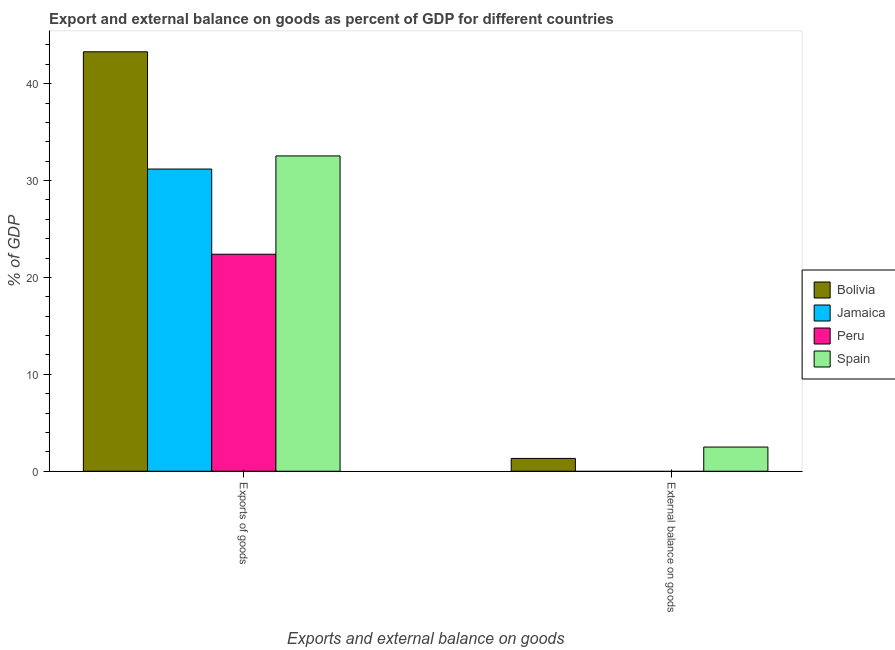How many different coloured bars are there?
Offer a very short reply. 4. How many groups of bars are there?
Ensure brevity in your answer.  2. Are the number of bars on each tick of the X-axis equal?
Your answer should be compact. No. What is the label of the 1st group of bars from the left?
Provide a succinct answer. Exports of goods. What is the external balance on goods as percentage of gdp in Jamaica?
Give a very brief answer. 0. Across all countries, what is the maximum external balance on goods as percentage of gdp?
Your response must be concise. 2.49. What is the total external balance on goods as percentage of gdp in the graph?
Ensure brevity in your answer.  3.82. What is the difference between the export of goods as percentage of gdp in Peru and that in Spain?
Give a very brief answer. -10.15. What is the difference between the external balance on goods as percentage of gdp in Jamaica and the export of goods as percentage of gdp in Spain?
Provide a short and direct response. -32.55. What is the average external balance on goods as percentage of gdp per country?
Provide a succinct answer. 0.95. What is the difference between the export of goods as percentage of gdp and external balance on goods as percentage of gdp in Bolivia?
Offer a very short reply. 41.97. In how many countries, is the external balance on goods as percentage of gdp greater than 8 %?
Your answer should be very brief. 0. What is the ratio of the export of goods as percentage of gdp in Bolivia to that in Peru?
Provide a short and direct response. 1.93. Is the export of goods as percentage of gdp in Jamaica less than that in Peru?
Provide a succinct answer. No. Are all the bars in the graph horizontal?
Ensure brevity in your answer.  No. How many countries are there in the graph?
Keep it short and to the point. 4. Are the values on the major ticks of Y-axis written in scientific E-notation?
Your answer should be very brief. No. Does the graph contain any zero values?
Your answer should be compact. Yes. How many legend labels are there?
Provide a short and direct response. 4. What is the title of the graph?
Your answer should be very brief. Export and external balance on goods as percent of GDP for different countries. What is the label or title of the X-axis?
Provide a short and direct response. Exports and external balance on goods. What is the label or title of the Y-axis?
Offer a terse response. % of GDP. What is the % of GDP in Bolivia in Exports of goods?
Make the answer very short. 43.29. What is the % of GDP of Jamaica in Exports of goods?
Keep it short and to the point. 31.19. What is the % of GDP of Peru in Exports of goods?
Offer a terse response. 22.4. What is the % of GDP of Spain in Exports of goods?
Offer a terse response. 32.55. What is the % of GDP in Bolivia in External balance on goods?
Your answer should be compact. 1.32. What is the % of GDP in Jamaica in External balance on goods?
Your answer should be compact. 0. What is the % of GDP of Spain in External balance on goods?
Your response must be concise. 2.49. Across all Exports and external balance on goods, what is the maximum % of GDP in Bolivia?
Make the answer very short. 43.29. Across all Exports and external balance on goods, what is the maximum % of GDP of Jamaica?
Offer a very short reply. 31.19. Across all Exports and external balance on goods, what is the maximum % of GDP in Peru?
Give a very brief answer. 22.4. Across all Exports and external balance on goods, what is the maximum % of GDP in Spain?
Offer a terse response. 32.55. Across all Exports and external balance on goods, what is the minimum % of GDP in Bolivia?
Make the answer very short. 1.32. Across all Exports and external balance on goods, what is the minimum % of GDP of Jamaica?
Keep it short and to the point. 0. Across all Exports and external balance on goods, what is the minimum % of GDP of Spain?
Your answer should be very brief. 2.49. What is the total % of GDP of Bolivia in the graph?
Offer a very short reply. 44.61. What is the total % of GDP in Jamaica in the graph?
Keep it short and to the point. 31.19. What is the total % of GDP of Peru in the graph?
Make the answer very short. 22.4. What is the total % of GDP in Spain in the graph?
Offer a terse response. 35.04. What is the difference between the % of GDP in Bolivia in Exports of goods and that in External balance on goods?
Ensure brevity in your answer.  41.97. What is the difference between the % of GDP of Spain in Exports of goods and that in External balance on goods?
Give a very brief answer. 30.05. What is the difference between the % of GDP in Bolivia in Exports of goods and the % of GDP in Spain in External balance on goods?
Your answer should be very brief. 40.8. What is the difference between the % of GDP of Jamaica in Exports of goods and the % of GDP of Spain in External balance on goods?
Your answer should be compact. 28.7. What is the difference between the % of GDP in Peru in Exports of goods and the % of GDP in Spain in External balance on goods?
Your response must be concise. 19.9. What is the average % of GDP of Bolivia per Exports and external balance on goods?
Offer a very short reply. 22.31. What is the average % of GDP in Jamaica per Exports and external balance on goods?
Your answer should be very brief. 15.6. What is the average % of GDP in Peru per Exports and external balance on goods?
Your answer should be compact. 11.2. What is the average % of GDP in Spain per Exports and external balance on goods?
Provide a succinct answer. 17.52. What is the difference between the % of GDP in Bolivia and % of GDP in Jamaica in Exports of goods?
Ensure brevity in your answer.  12.1. What is the difference between the % of GDP in Bolivia and % of GDP in Peru in Exports of goods?
Offer a terse response. 20.89. What is the difference between the % of GDP in Bolivia and % of GDP in Spain in Exports of goods?
Offer a terse response. 10.75. What is the difference between the % of GDP in Jamaica and % of GDP in Peru in Exports of goods?
Your answer should be compact. 8.79. What is the difference between the % of GDP of Jamaica and % of GDP of Spain in Exports of goods?
Ensure brevity in your answer.  -1.35. What is the difference between the % of GDP in Peru and % of GDP in Spain in Exports of goods?
Your answer should be compact. -10.15. What is the difference between the % of GDP of Bolivia and % of GDP of Spain in External balance on goods?
Your answer should be compact. -1.17. What is the ratio of the % of GDP in Bolivia in Exports of goods to that in External balance on goods?
Your answer should be compact. 32.76. What is the ratio of the % of GDP in Spain in Exports of goods to that in External balance on goods?
Give a very brief answer. 13.05. What is the difference between the highest and the second highest % of GDP in Bolivia?
Your response must be concise. 41.97. What is the difference between the highest and the second highest % of GDP in Spain?
Give a very brief answer. 30.05. What is the difference between the highest and the lowest % of GDP of Bolivia?
Your answer should be very brief. 41.97. What is the difference between the highest and the lowest % of GDP in Jamaica?
Keep it short and to the point. 31.19. What is the difference between the highest and the lowest % of GDP in Peru?
Your response must be concise. 22.4. What is the difference between the highest and the lowest % of GDP in Spain?
Make the answer very short. 30.05. 